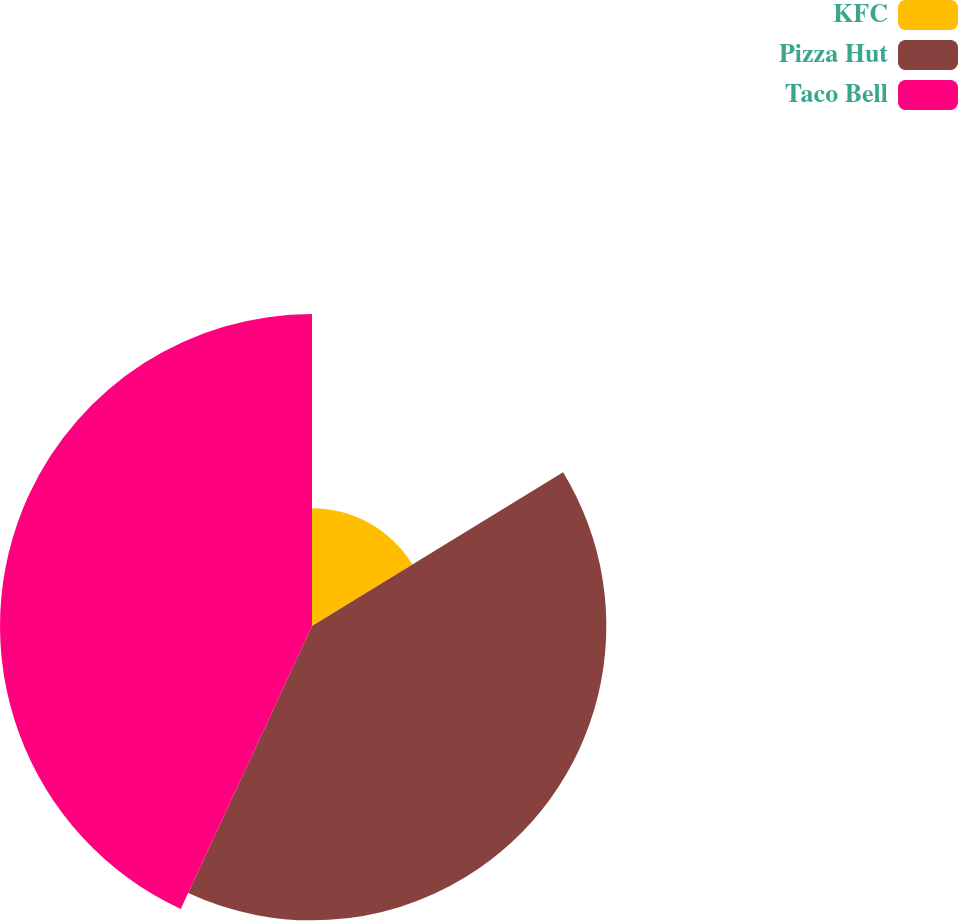<chart> <loc_0><loc_0><loc_500><loc_500><pie_chart><fcel>KFC<fcel>Pizza Hut<fcel>Taco Bell<nl><fcel>16.26%<fcel>40.65%<fcel>43.09%<nl></chart> 